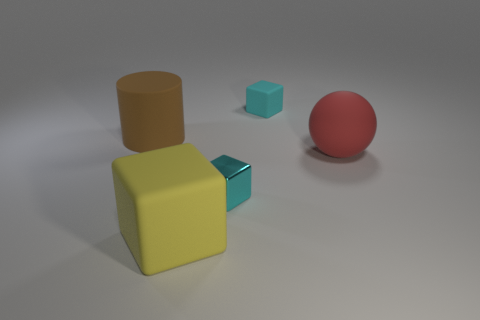Subtract all tiny shiny cubes. How many cubes are left? 2 Subtract all blue spheres. How many cyan blocks are left? 2 Subtract all yellow blocks. How many blocks are left? 2 Add 4 large cubes. How many objects exist? 9 Subtract all cubes. How many objects are left? 2 Subtract 1 cubes. How many cubes are left? 2 Add 5 yellow blocks. How many yellow blocks exist? 6 Subtract 0 purple blocks. How many objects are left? 5 Subtract all green blocks. Subtract all blue cylinders. How many blocks are left? 3 Subtract all green cubes. Subtract all big matte things. How many objects are left? 2 